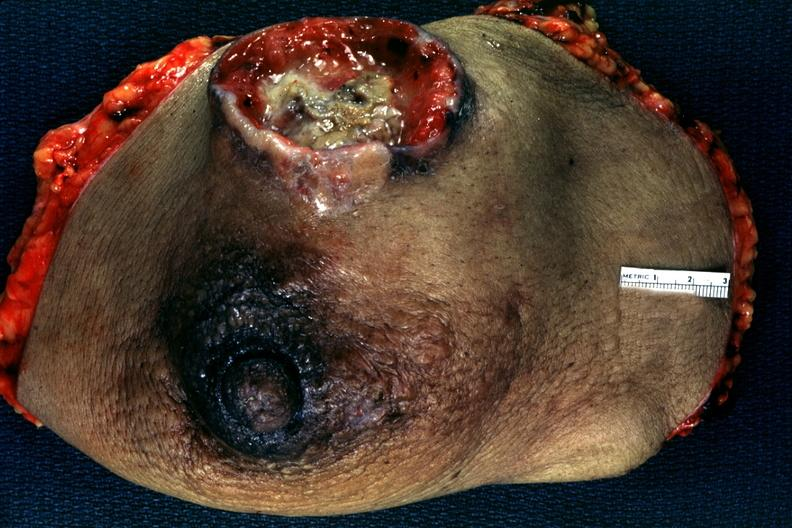s breast present?
Answer the question using a single word or phrase. Yes 